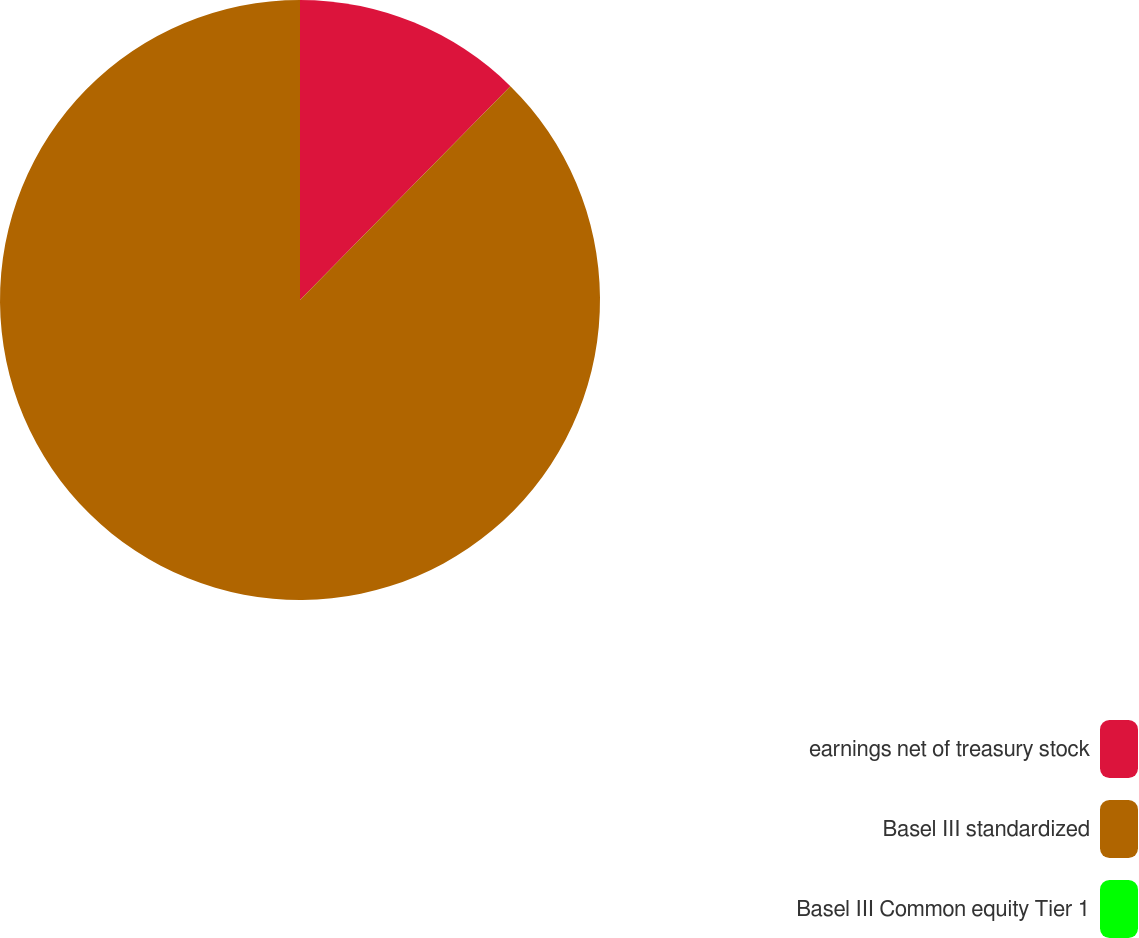<chart> <loc_0><loc_0><loc_500><loc_500><pie_chart><fcel>earnings net of treasury stock<fcel>Basel III standardized<fcel>Basel III Common equity Tier 1<nl><fcel>12.37%<fcel>87.62%<fcel>0.0%<nl></chart> 